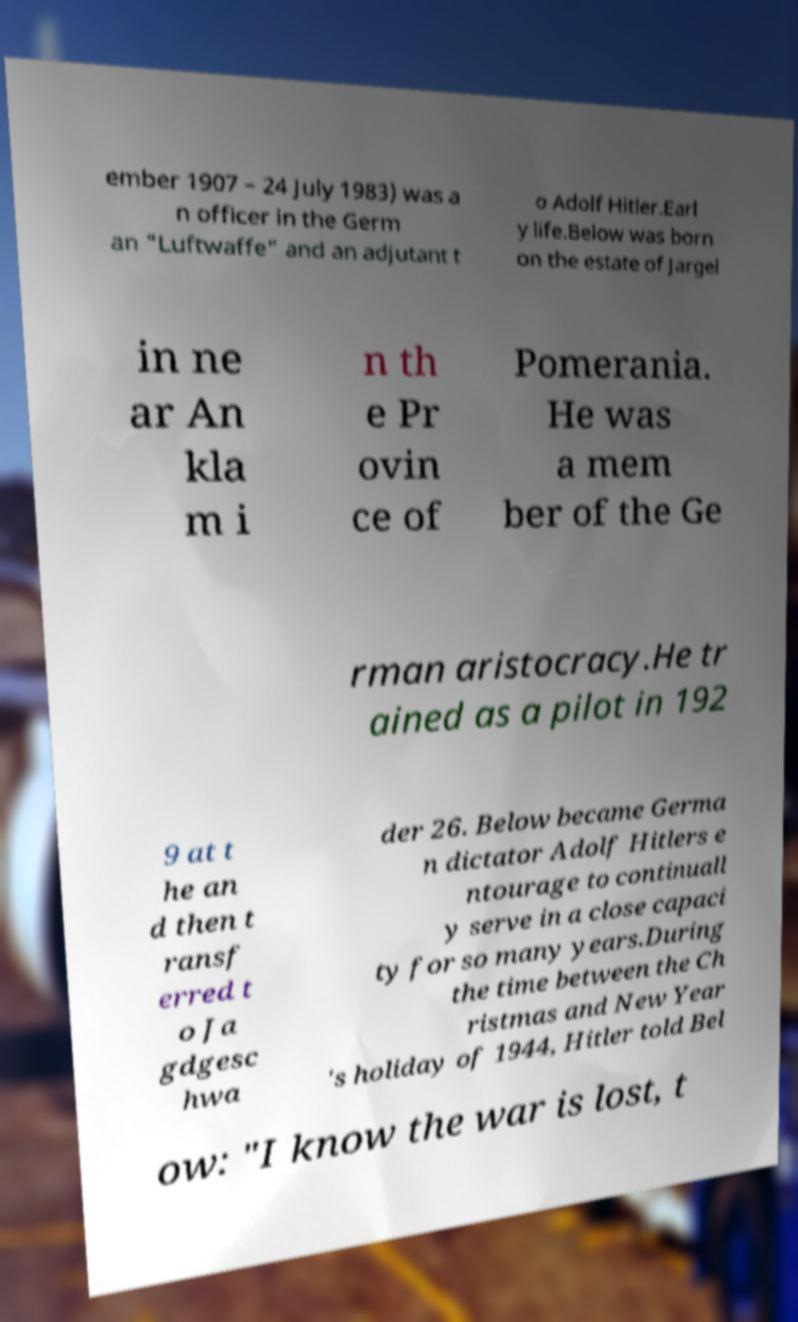Could you extract and type out the text from this image? ember 1907 – 24 July 1983) was a n officer in the Germ an "Luftwaffe" and an adjutant t o Adolf Hitler.Earl y life.Below was born on the estate of Jargel in ne ar An kla m i n th e Pr ovin ce of Pomerania. He was a mem ber of the Ge rman aristocracy.He tr ained as a pilot in 192 9 at t he an d then t ransf erred t o Ja gdgesc hwa der 26. Below became Germa n dictator Adolf Hitlers e ntourage to continuall y serve in a close capaci ty for so many years.During the time between the Ch ristmas and New Year 's holiday of 1944, Hitler told Bel ow: "I know the war is lost, t 